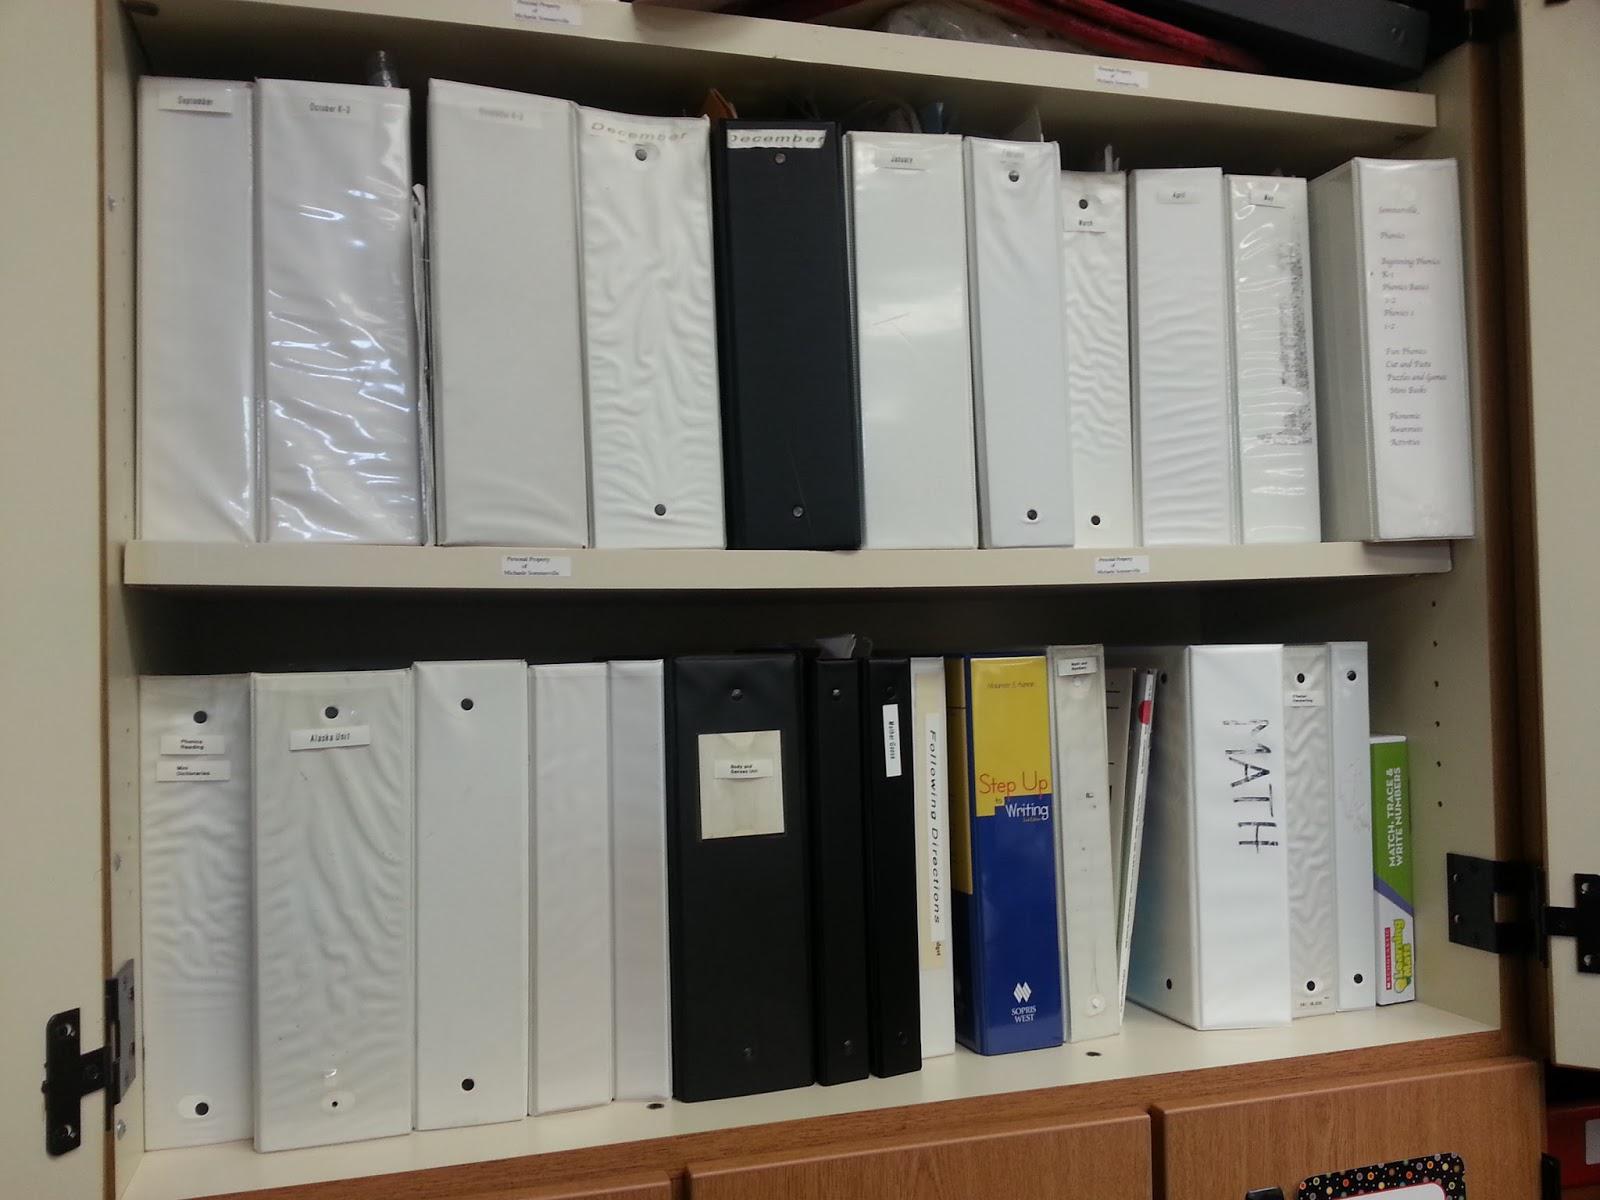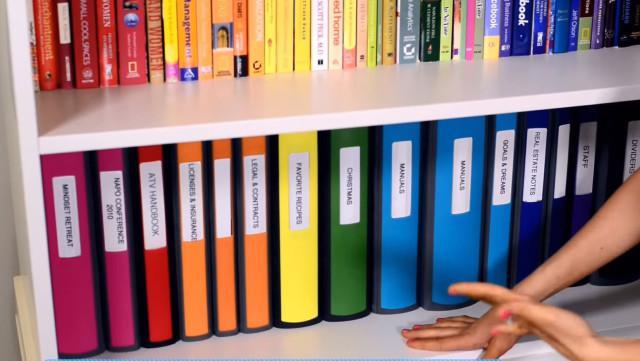The first image is the image on the left, the second image is the image on the right. Assess this claim about the two images: "Exactly six binders of equal size are shown in one image.". Correct or not? Answer yes or no. No. The first image is the image on the left, the second image is the image on the right. For the images shown, is this caption "1 of the images has 6 shelf objects lined up in a row next to each other." true? Answer yes or no. No. 